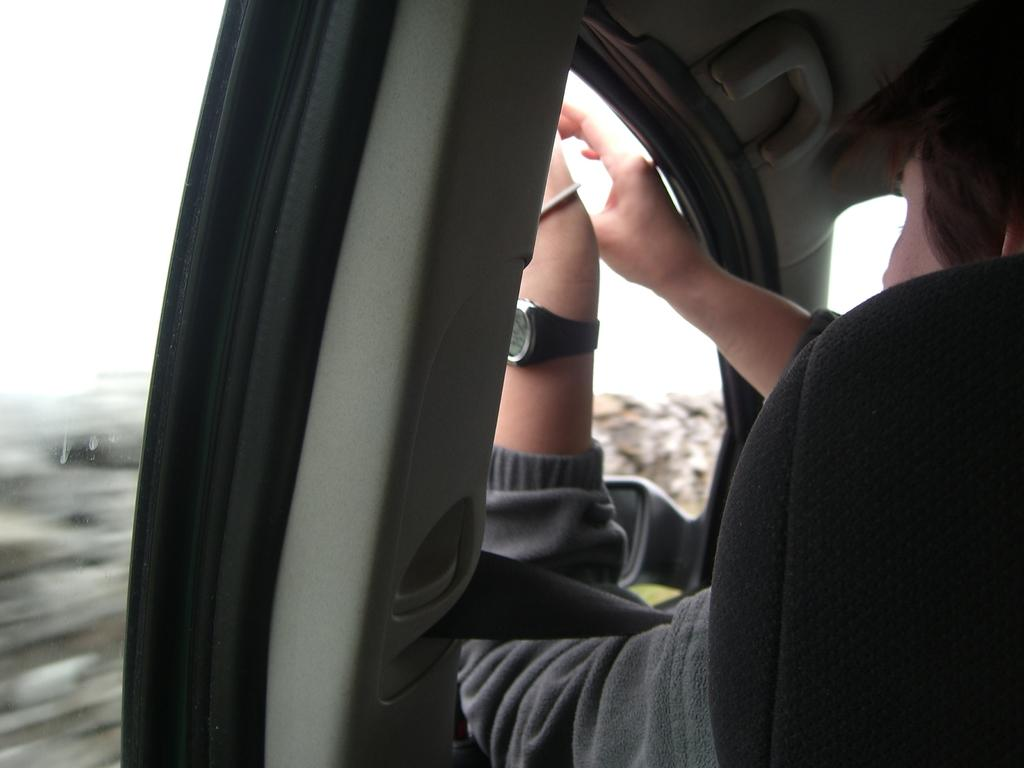What is the main subject of the image? There is a person in the image. What is the person doing in the image? The person is sitting in a vehicle. Is the person taking any safety precautions in the image? Yes, the person is wearing a seat belt. What type of accessory is the person wearing in the image? The person is wearing a wrist watch. What type of bell can be heard ringing in the image? There is no bell present or ringing in the image. Is the person in the image part of an army? There is no indication in the image that the person is part of an army. 